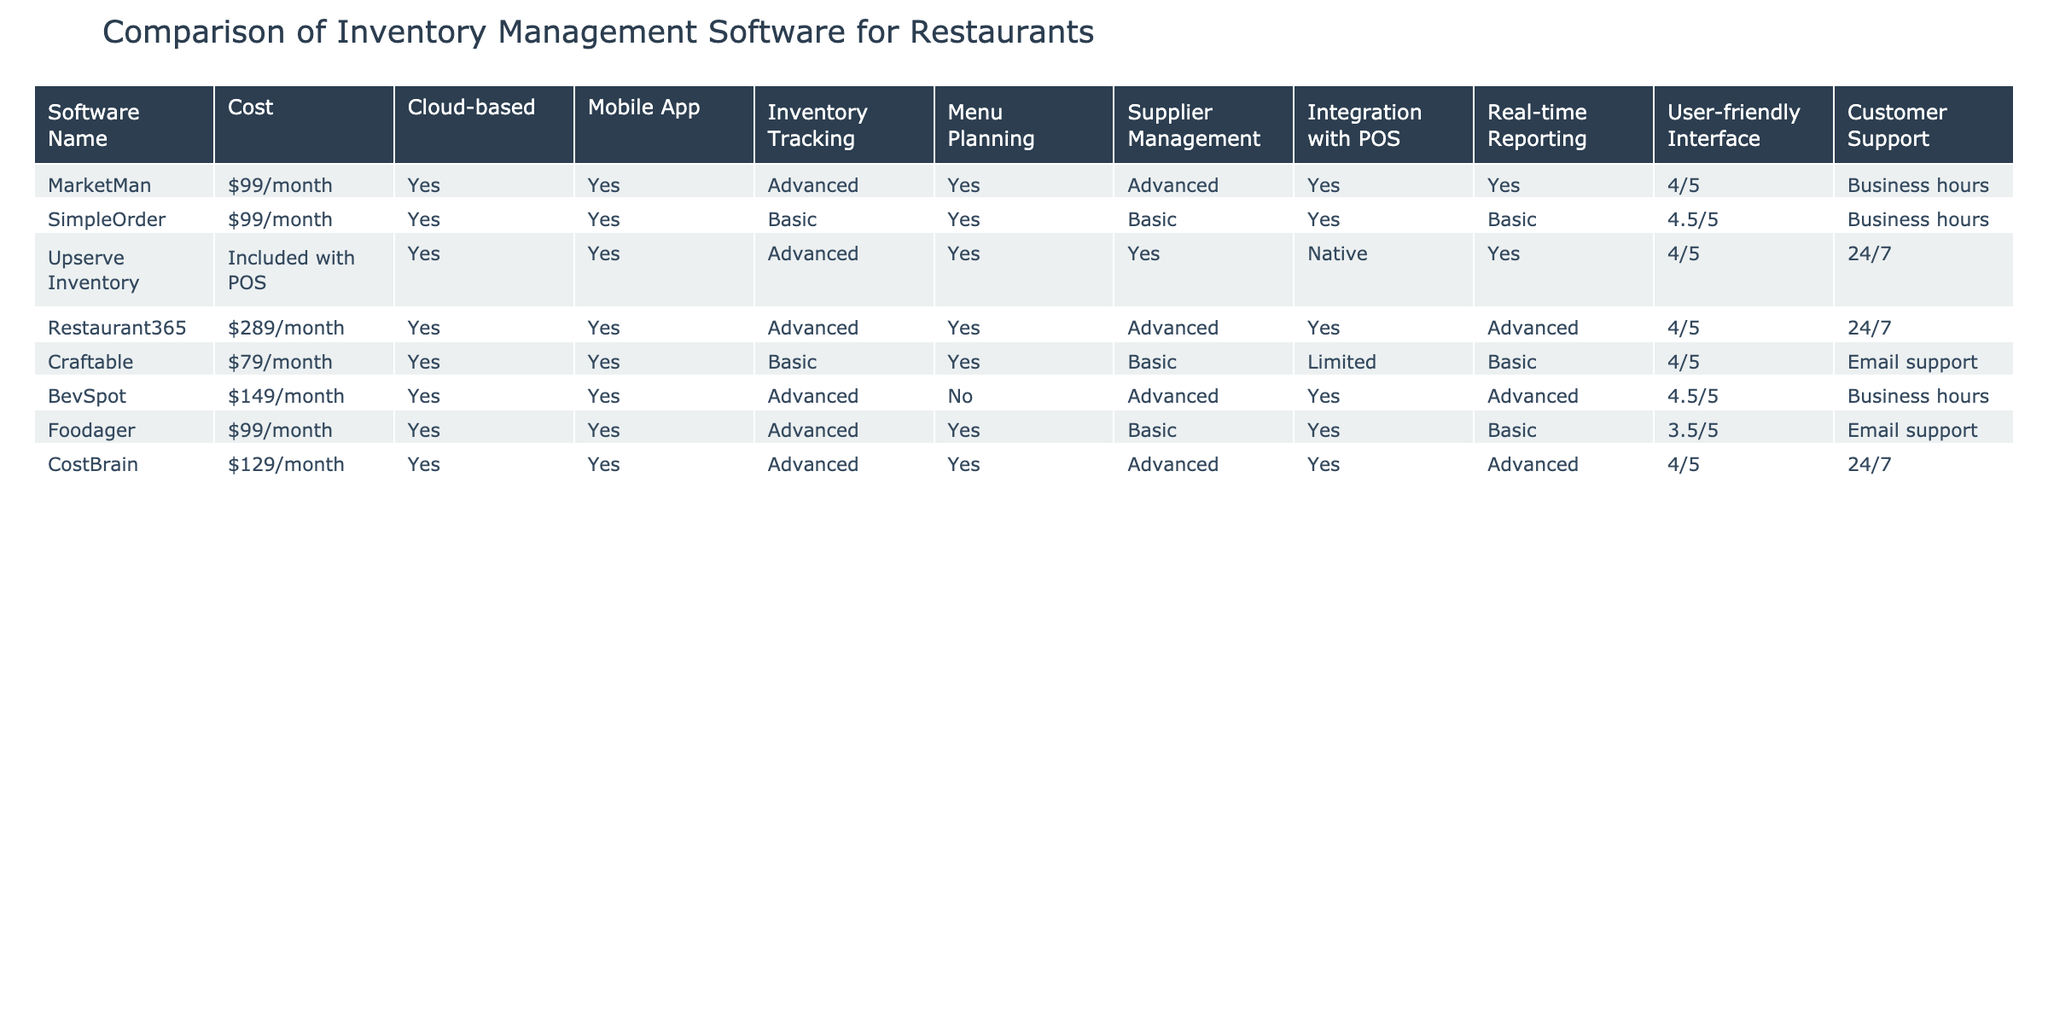What is the cost of MarketMan? The table lists the cost of MarketMan in the 'Cost' column, which shows it as $99/month.
Answer: $99/month Which software has the most advanced inventory tracking feature? Looking at the 'Inventory Tracking' column, both MarketMan, Upserve Inventory, Restaurant365, BevSpot, CostBrain offer 'Advanced' tracking, which is the highest level available in the table.
Answer: MarketMan, Upserve Inventory, Restaurant365, BevSpot, CostBrain Does Craftable have a mobile app? The 'Mobile App' column indicates 'Yes' for Craftable, confirming that this software does provide a mobile application.
Answer: Yes What is the average cost of the software listed in the table? To find the average cost, we first need to convert the costs to numerical values. The costs are as follows: $99, $99, $129, $289, $79, $149, $99. The total is $999. There are 7 entries, so the average cost is $999/7, which equals approximately $142.71.
Answer: $142.71 Which software has 24/7 customer support and is also cloud-based? We check the 'Customer Support' column for 24/7 options and the 'Cloud-based' column. Both Upserve Inventory and Restaurant365 provide 24/7 support and are cloud-based, making them the correct answers.
Answer: Upserve Inventory, Restaurant365 